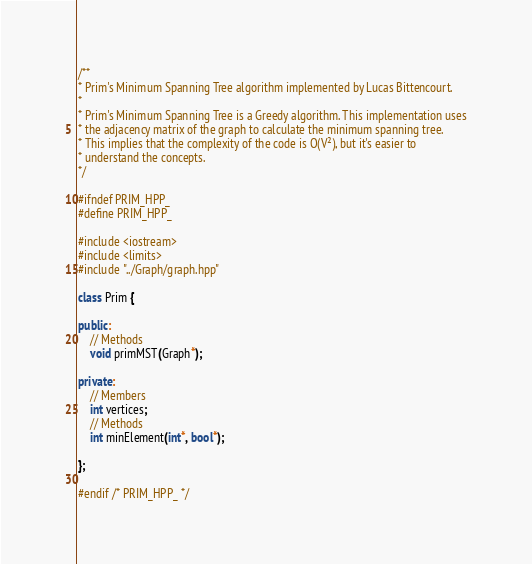<code> <loc_0><loc_0><loc_500><loc_500><_C++_>/**
* Prim's Minimum Spanning Tree algorithm implemented by Lucas Bittencourt.
*
* Prim's Minimum Spanning Tree is a Greedy algorithm. This implementation uses
* the adjacency matrix of the graph to calculate the minimum spanning tree.
* This implies that the complexity of the code is O(V²), but it's easier to
* understand the concepts.
*/

#ifndef PRIM_HPP_
#define PRIM_HPP_

#include <iostream>
#include <limits>
#include "../Graph/graph.hpp"

class Prim {

public:
    // Methods
    void primMST(Graph*);

private:
    // Members
    int vertices;
    // Methods
    int minElement(int*, bool*);

};

#endif /* PRIM_HPP_ */
</code> 